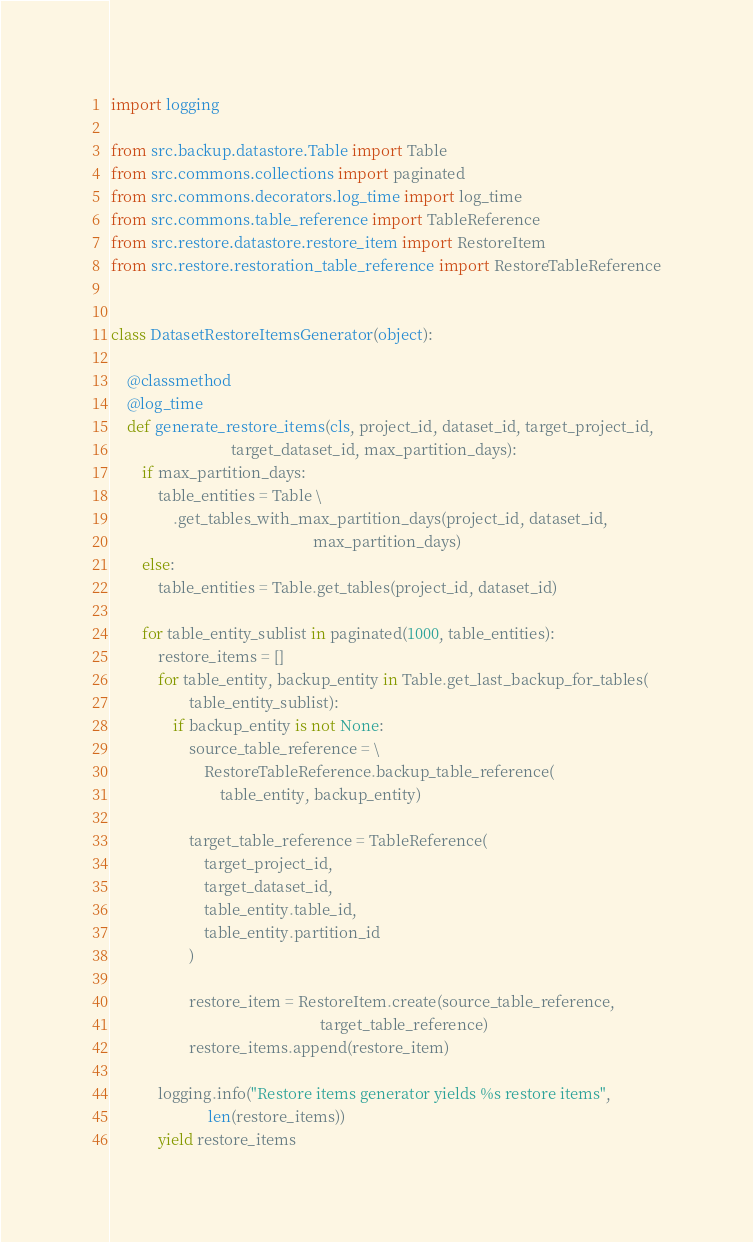Convert code to text. <code><loc_0><loc_0><loc_500><loc_500><_Python_>import logging

from src.backup.datastore.Table import Table
from src.commons.collections import paginated
from src.commons.decorators.log_time import log_time
from src.commons.table_reference import TableReference
from src.restore.datastore.restore_item import RestoreItem
from src.restore.restoration_table_reference import RestoreTableReference


class DatasetRestoreItemsGenerator(object):

    @classmethod
    @log_time
    def generate_restore_items(cls, project_id, dataset_id, target_project_id,
                               target_dataset_id, max_partition_days):
        if max_partition_days:
            table_entities = Table \
                .get_tables_with_max_partition_days(project_id, dataset_id,
                                                    max_partition_days)
        else:
            table_entities = Table.get_tables(project_id, dataset_id)

        for table_entity_sublist in paginated(1000, table_entities):
            restore_items = []
            for table_entity, backup_entity in Table.get_last_backup_for_tables(
                    table_entity_sublist):
                if backup_entity is not None:
                    source_table_reference = \
                        RestoreTableReference.backup_table_reference(
                            table_entity, backup_entity)

                    target_table_reference = TableReference(
                        target_project_id,
                        target_dataset_id,
                        table_entity.table_id,
                        table_entity.partition_id
                    )

                    restore_item = RestoreItem.create(source_table_reference,
                                                      target_table_reference)
                    restore_items.append(restore_item)

            logging.info("Restore items generator yields %s restore items",
                         len(restore_items))
            yield restore_items
</code> 